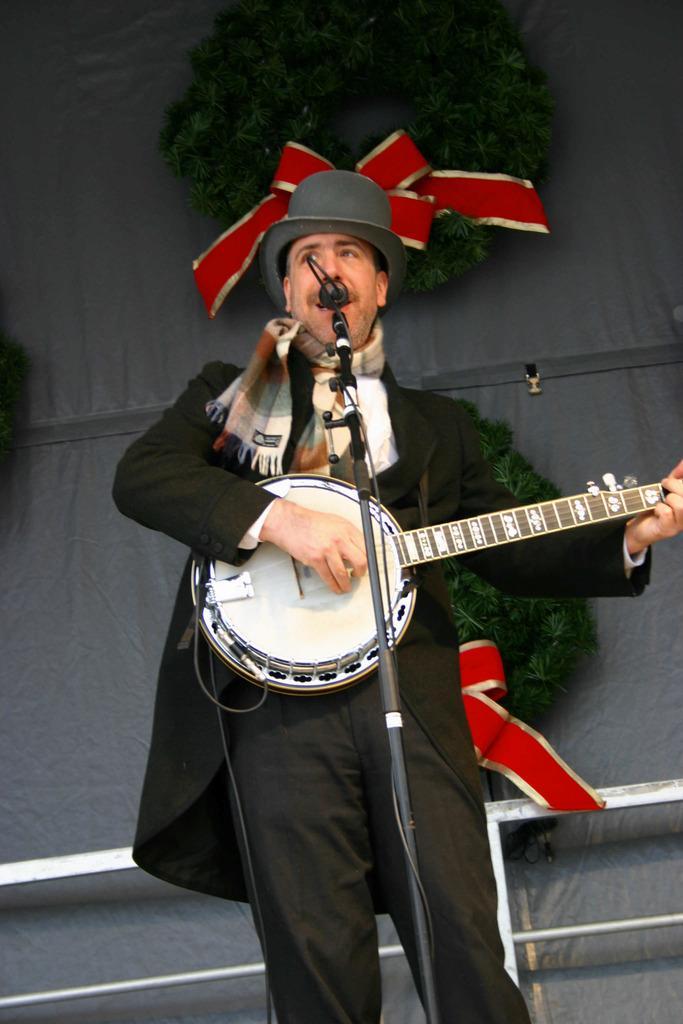How would you summarize this image in a sentence or two? In the picture we can see a man standing and playing a musical instrument and singing the song in the microphone and he is in a black dress and hat and behind him we can see the wall is decorated with ribbons and we can see a part of the railing. 